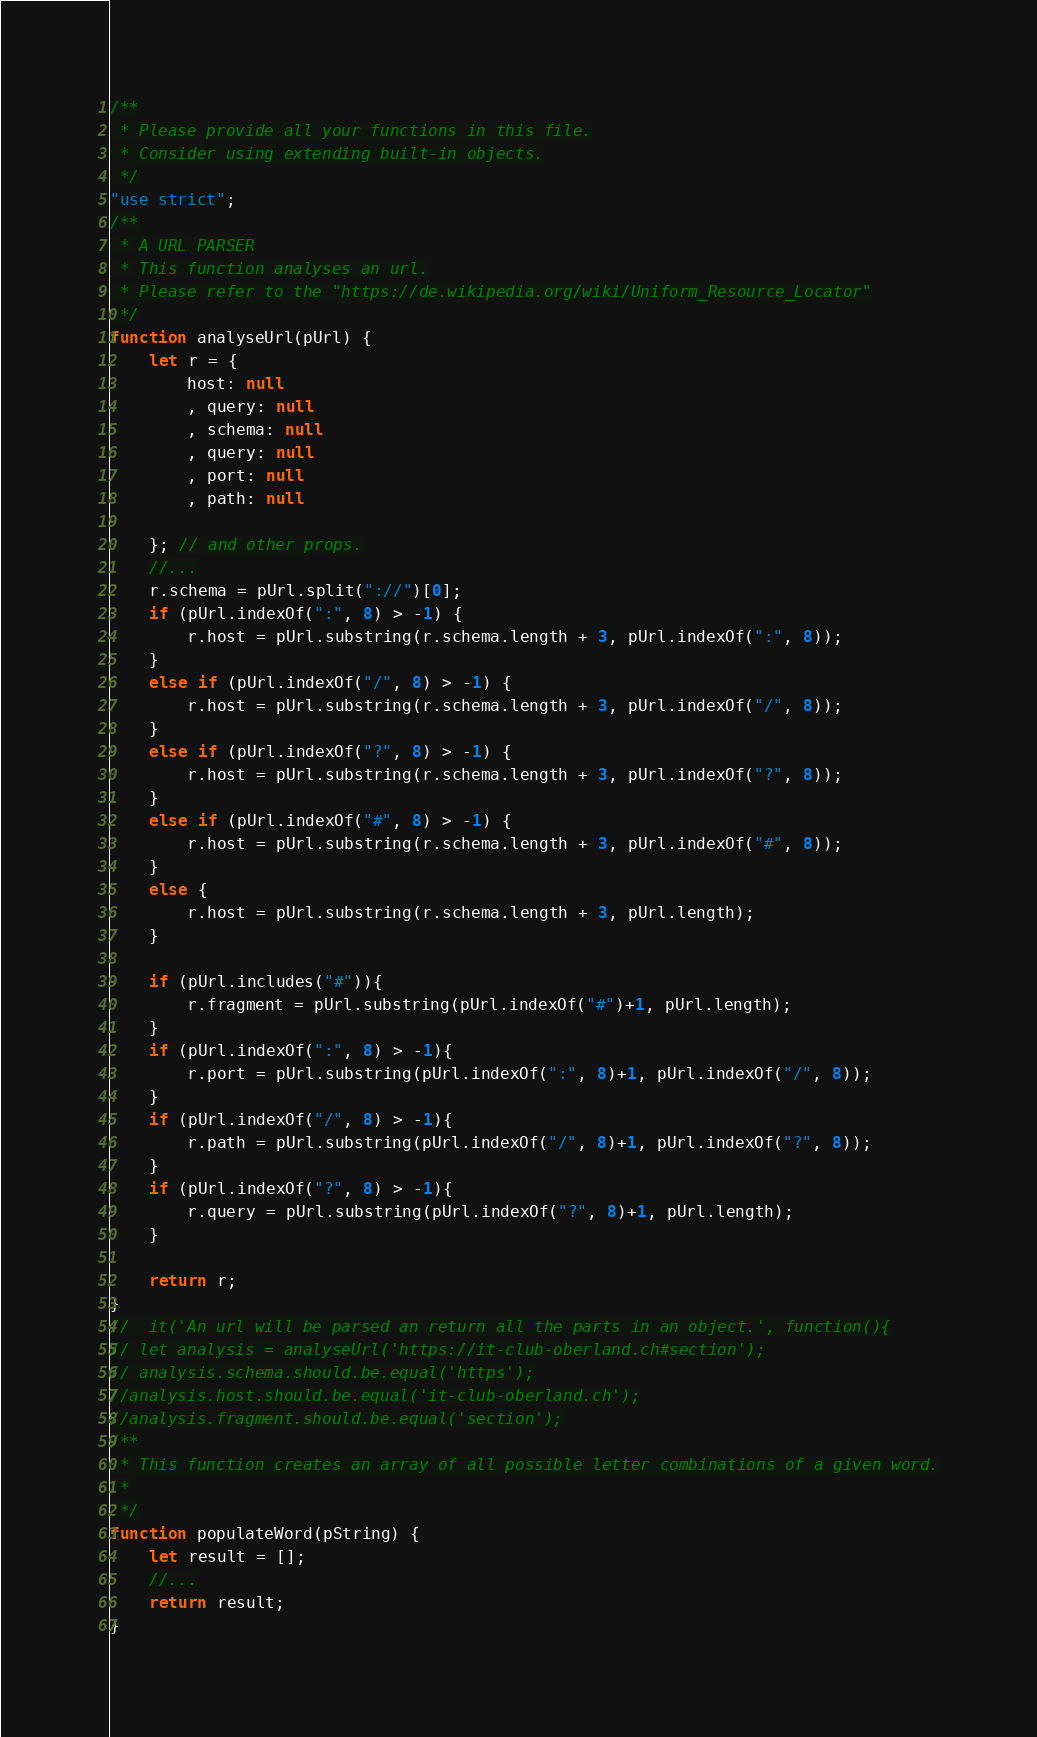Convert code to text. <code><loc_0><loc_0><loc_500><loc_500><_JavaScript_>/**
 * Please provide all your functions in this file.
 * Consider using extending built-in objects.
 */
"use strict";
/**
 * A URL PARSER
 * This function analyses an url.
 * Please refer to the "https://de.wikipedia.org/wiki/Uniform_Resource_Locator"
 */
function analyseUrl(pUrl) {
    let r = {
        host: null
        , query: null
        , schema: null
        , query: null
        , port: null
        , path: null
        
    }; // and other props.
    //...
    r.schema = pUrl.split("://")[0];
    if (pUrl.indexOf(":", 8) > -1) {
        r.host = pUrl.substring(r.schema.length + 3, pUrl.indexOf(":", 8));
    }
    else if (pUrl.indexOf("/", 8) > -1) {
        r.host = pUrl.substring(r.schema.length + 3, pUrl.indexOf("/", 8));
    }
    else if (pUrl.indexOf("?", 8) > -1) {
        r.host = pUrl.substring(r.schema.length + 3, pUrl.indexOf("?", 8));
    }
    else if (pUrl.indexOf("#", 8) > -1) {
        r.host = pUrl.substring(r.schema.length + 3, pUrl.indexOf("#", 8));
    }
    else {
        r.host = pUrl.substring(r.schema.length + 3, pUrl.length);
    }
    
    if (pUrl.includes("#")){
        r.fragment = pUrl.substring(pUrl.indexOf("#")+1, pUrl.length);
    }
    if (pUrl.indexOf(":", 8) > -1){
        r.port = pUrl.substring(pUrl.indexOf(":", 8)+1, pUrl.indexOf("/", 8));
    } 
    if (pUrl.indexOf("/", 8) > -1){
        r.path = pUrl.substring(pUrl.indexOf("/", 8)+1, pUrl.indexOf("?", 8));
    }
    if (pUrl.indexOf("?", 8) > -1){
        r.query = pUrl.substring(pUrl.indexOf("?", 8)+1, pUrl.length);
    }
    
    return r;
}
//  it('An url will be parsed an return all the parts in an object.', function(){
// let analysis = analyseUrl('https://it-club-oberland.ch#section');
// analysis.schema.should.be.equal('https');
//analysis.host.should.be.equal('it-club-oberland.ch');
//analysis.fragment.should.be.equal('section');
/**
 * This function creates an array of all possible letter combinations of a given word.
 *
 */
function populateWord(pString) {
    let result = [];
    //...
    return result;
}</code> 